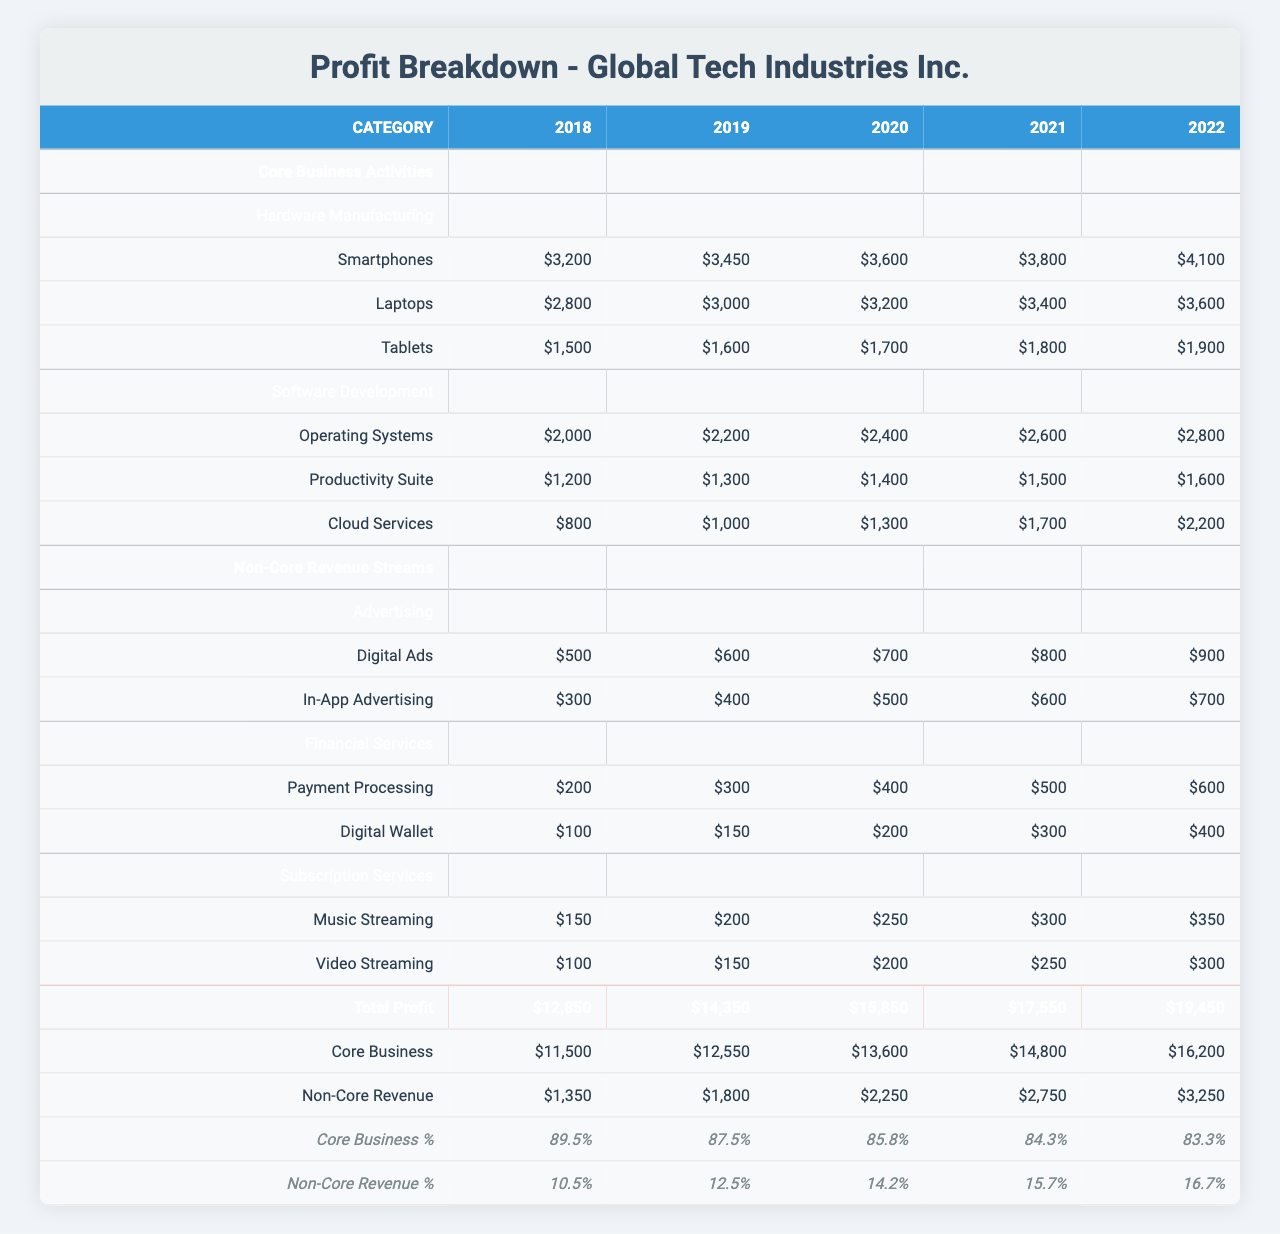What was the total profit from core business activities in 2022? The total profit from core business activities in 2022 is listed in the table as $16,200. This value can be found directly under the "Core Business" row in the "Total Profit" section for 2022.
Answer: $16,200 What percentage did non-core revenue contribute to overall profit in 2020? For the year 2020, the non-core revenue contributed 14.2% to the overall profit. This percentage can be observed in the "Profit Contribution Percentage" section under "Non-Core Revenue" for the year 2020.
Answer: 14.2% What was the yearly increase in total profit from 2018 to 2022? To calculate the yearly increase in total profit from 2018 to 2022, we subtract the total profit of 2018 ($12,850) from that of 2022 ($19,450), which results in a difference of $6,600. This sum indicates the total increase over 5 years.
Answer: $6,600 Did the profit from digital ads increase every year from 2018 to 2022? By examining the values for digital ads from 2018 ($500) to 2022 ($900) in the table, it is evident that the profit from digital ads did indeed increase each year, confirming a consistent upward trend.
Answer: Yes What was the core business profit in 2019, and how does it compare to the non-core revenue profit in the same year? The core business profit in 2019 is $12,550, while the non-core revenue profit for the same year amounts to $1,800. The difference between them is $12,550 - $1,800 = $10,750, indicating that core business profit is significantly higher.
Answer: $10,750 Which non-core revenue stream had the highest profit in 2022, and what was that amount? In 2022, the non-core revenue stream with the highest profit was digital ads, which earned $900. This can be confirmed by checking the values listed for each non-core revenue stream in the "Non-Core Revenue Streams" section for that year.
Answer: $900 How much did the profit from payment processing grow from 2018 to 2022? The profit from payment processing in 2018 was $200, and in 2022 it rose to $600. The growth can be calculated as $600 - $200 = $400, showing significant growth over these years.
Answer: $400 Is the profit contribution percentage of core business decreasing over the years? The values for core business profit contribution percentage show a steady decrease from 89.5% in 2018 to 83.3% in 2022, indicating a confirmed downward trend. Thus, we can conclude that the dominance of core business profits is waning relative to overall profit.
Answer: Yes What is the average profit from hardware manufacturing across the five years? To find the average profit from hardware manufacturing, we need to sum the profits from smartphones, laptops, and tablets over the five years, resulting in a total of $20,600. Dividing this by the five years gives an average of $4,120.
Answer: $4,120 What was the total profit from subscription services over the 5-year period? The total profit from subscription services can be calculated by adding the profits from music streaming and video streaming for each year, which equals $2000 (music) + $1500 (video) = $3500 in 2022, and the respective profits for the other years, resulting in a total of $9,800 across the five years.
Answer: $9,800 In which year did the profit contribution percentage of non-core revenue exceed 15% for the first time? The non-core revenue profit contribution percentage exceeded 15% for the first time in 2021 when it was reported at 15.7%. This can be found in the "Profit Contribution Percentage" section under "Non-Core Revenue" for the respective years.
Answer: 2021 